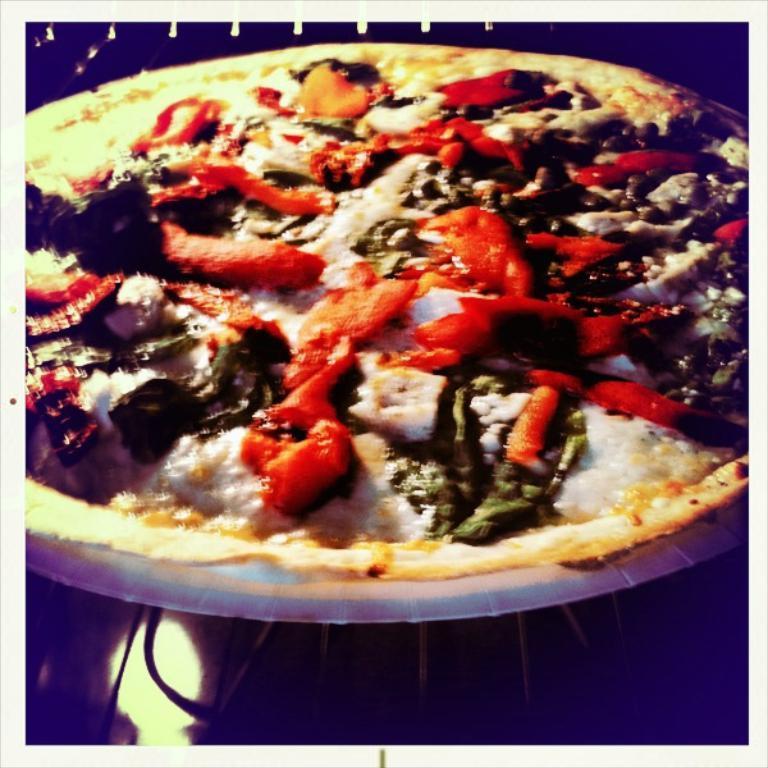Describe this image in one or two sentences. In this picture we can see a food item on a plate and this plate is on a platform. 